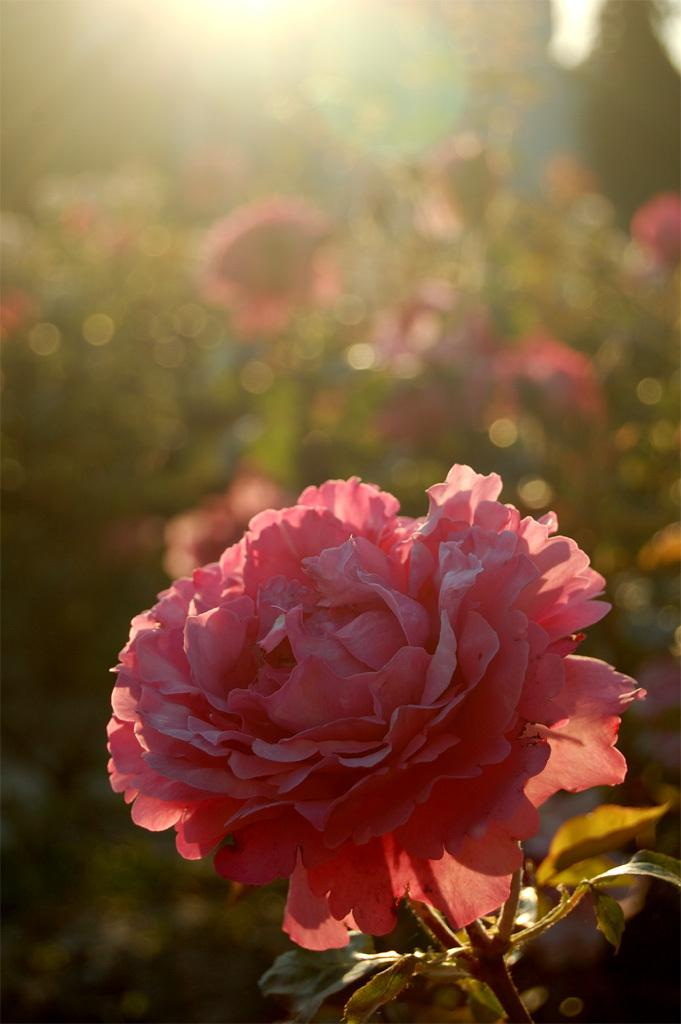What type of flower is in the image? There is a pink rose flower in the image. What color are the leaves of the flower? The rose flower has green leaves. Is the flower fully open or closed in the image? The flower is blooming in the image. What is the lighting condition in the image? The image shows the flower in sunlight. Where is the stove located in the image? There is no stove present in the image; it features a pink rose flower with green leaves. Can you see any icicles hanging from the flower in the image? There are no icicles present in the image; it shows a flower in sunlight. 